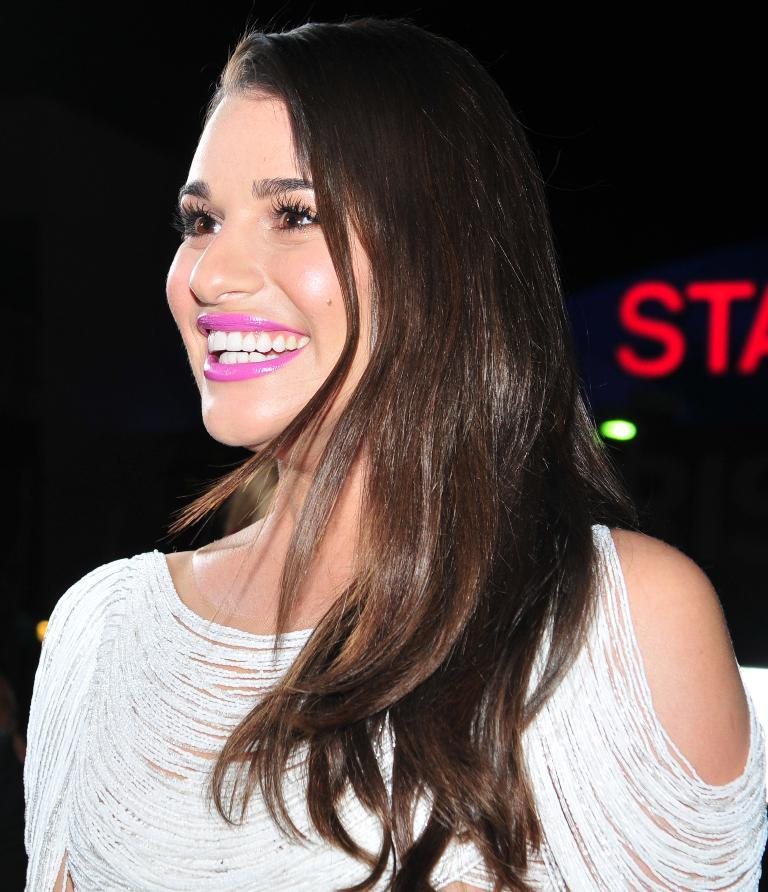Who is the main subject in the foreground of the image? There is a woman in the foreground of the image. What is the woman wearing? The woman is wearing a white dress. What is the woman's facial expression in the image? The woman is smiling. What is the color of the background in the image? The background of the image is black. What can be seen in the image besides the woman? Lights and text are visible in the image. What type of plastic is used to create the bit in the image? There is no bit or plastic present in the image. How is the thread used in the image? There is no thread present in the image. 